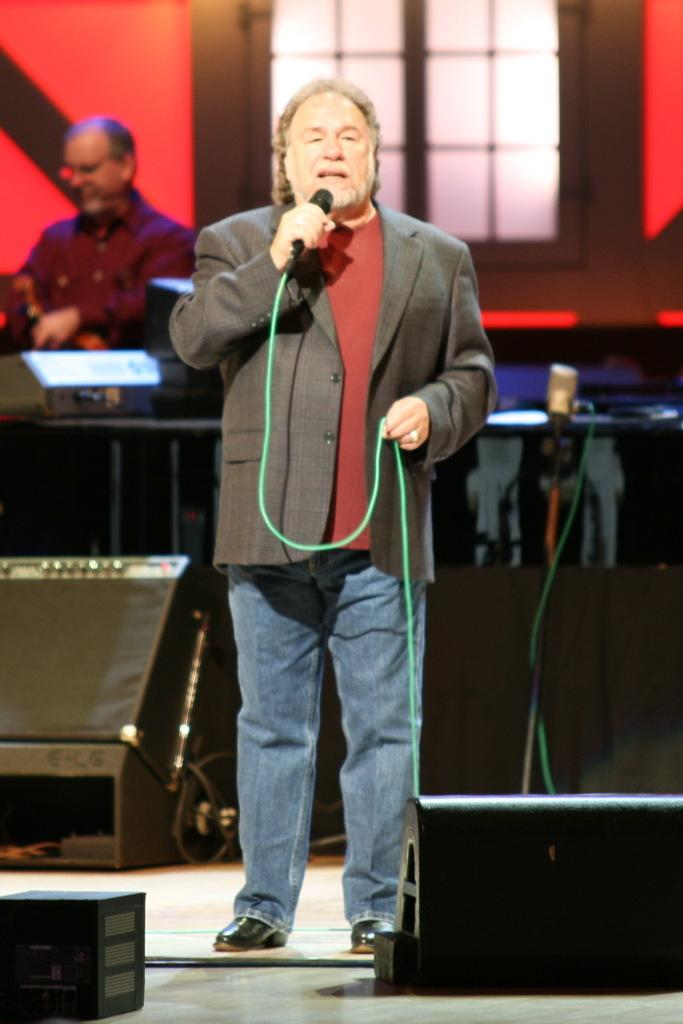What is the person in the image doing? The person is standing in the image and holding a microphone. What can be seen in the background of the image? There is a wall, at least one person, and a glass window in the background of the image. What type of beds can be seen in the image? There are no beds present in the image. 